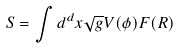<formula> <loc_0><loc_0><loc_500><loc_500>S = \int d ^ { d } x \sqrt { g } V ( \phi ) F ( R )</formula> 